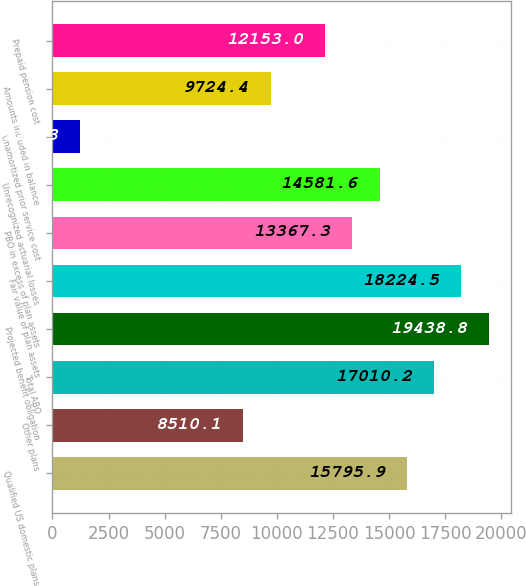Convert chart to OTSL. <chart><loc_0><loc_0><loc_500><loc_500><bar_chart><fcel>Qualified US domestic plans<fcel>Other plans<fcel>Total ABO<fcel>Projected benefit obligation<fcel>Fair value of plan assets<fcel>PBO in excess of plan assets<fcel>Unrecognized actuarial losses<fcel>Unamortized prior service cost<fcel>Amounts included in balance<fcel>Prepaid pension cost<nl><fcel>15795.9<fcel>8510.1<fcel>17010.2<fcel>19438.8<fcel>18224.5<fcel>13367.3<fcel>14581.6<fcel>1224.3<fcel>9724.4<fcel>12153<nl></chart> 